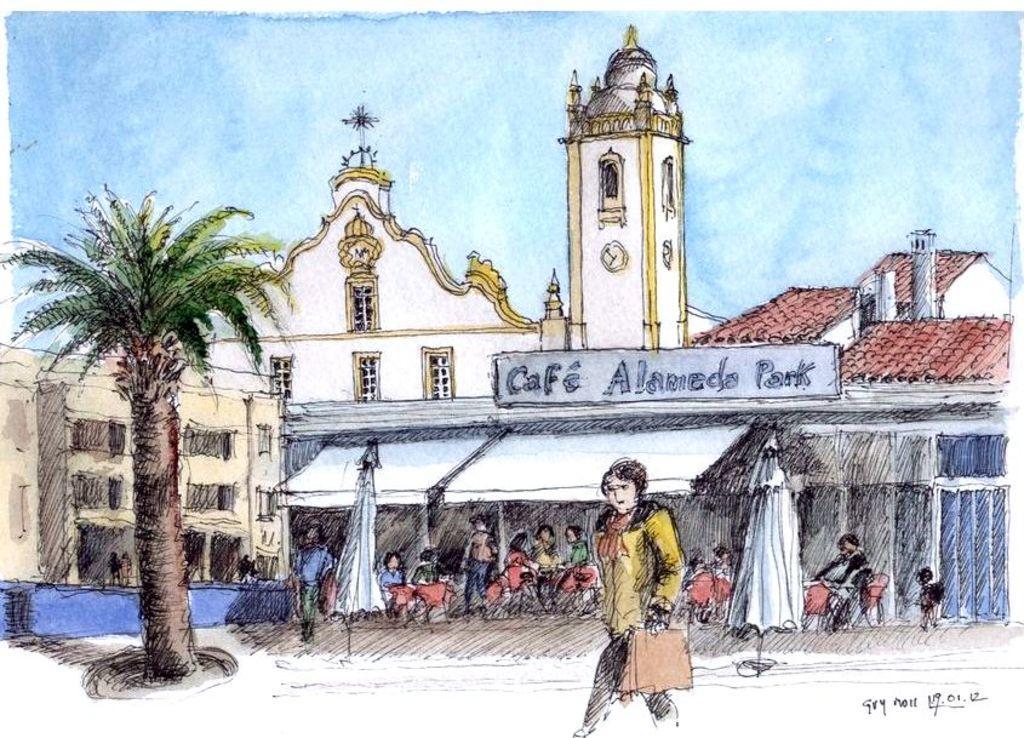Please provide a concise description of this image. In this image we can see there is a sketch of a building, in front of the building there are a few people standing and few are sitting on their chairs, there is a lady walking, behind the lady there are two canopy's, beside them there is a coconut tree. In the background there is the sky. 